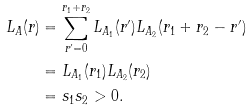<formula> <loc_0><loc_0><loc_500><loc_500>L _ { A } ( r ) & = \sum _ { r ^ { \prime } = 0 } ^ { r _ { 1 } + r _ { 2 } } L _ { A _ { 1 } } ( r ^ { \prime } ) L _ { A _ { 2 } } ( r _ { 1 } + r _ { 2 } - r ^ { \prime } ) \\ & = L _ { A _ { 1 } } ( r _ { 1 } ) L _ { A _ { 2 } } ( r _ { 2 } ) \\ & = s _ { 1 } s _ { 2 } > 0 .</formula> 